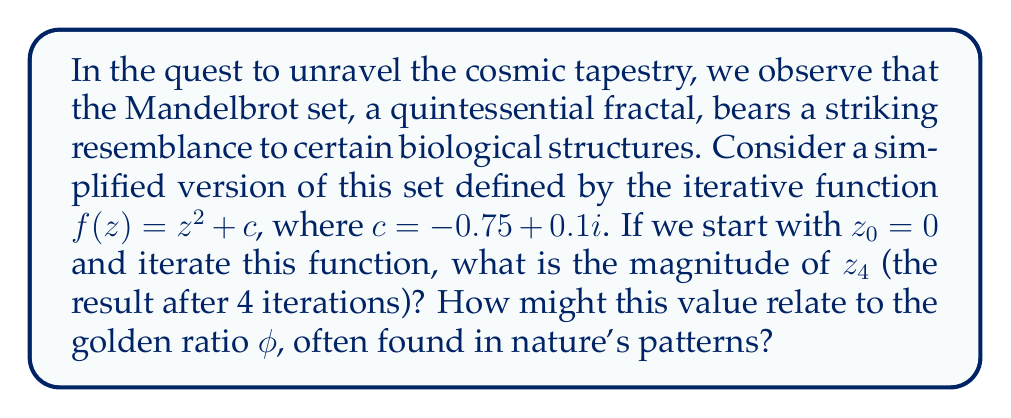Can you solve this math problem? Let's approach this cosmic dance of numbers step by step:

1) We start with $z_0 = 0$ and $c = -0.75 + 0.1i$

2) First iteration:
   $z_1 = f(z_0) = z_0^2 + c = 0^2 + (-0.75 + 0.1i) = -0.75 + 0.1i$

3) Second iteration:
   $z_2 = f(z_1) = (-0.75 + 0.1i)^2 + (-0.75 + 0.1i)$
   $= (0.5625 - 0.15i + 0.01i^2) + (-0.75 + 0.1i)$
   $= -0.1875 - 0.05i$

4) Third iteration:
   $z_3 = f(z_2) = (-0.1875 - 0.05i)^2 + (-0.75 + 0.1i)$
   $= (0.0351563 + 0.01875i + 0.0025i^2) + (-0.75 + 0.1i)$
   $= -0.7148437 + 0.11875i$

5) Fourth iteration:
   $z_4 = f(z_3) = (-0.7148437 + 0.11875i)^2 + (-0.75 + 0.1i)$
   $= (0.5110016 - 0.1695312i + 0.0140869i^2) + (-0.75 + 0.1i)$
   $= -0.2389984 - 0.0695312i$

6) The magnitude of a complex number $a + bi$ is given by $\sqrt{a^2 + b^2}$

   Therefore, $|z_4| = \sqrt{(-0.2389984)^2 + (-0.0695312)^2}$
   $= \sqrt{0.0571204 + 0.00483459} = \sqrt{0.06195499} \approx 0.2489077$

7) Interestingly, this value is close to $\frac{1}{\phi^2}$, where $\phi$ is the golden ratio:

   $\phi = \frac{1 + \sqrt{5}}{2} \approx 1.618034$
   $\frac{1}{\phi^2} \approx 0.381966$

   The difference between $|z_4|$ and $\frac{1}{\phi^2}$ is approximately 0.133058, which is close to $\frac{1}{2\phi} \approx 0.309017$

This cosmic coincidence hints at the deep connections between fractal geometry, complex dynamics, and the golden ratio, all of which are prevalent in biological structures and cosmic patterns.
Answer: $|z_4| \approx 0.2489077$, which is approximately $\frac{1}{\phi^2} - \frac{1}{2\phi}$, where $\phi$ is the golden ratio. 